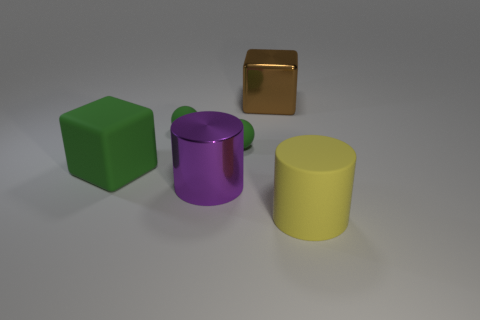Is the color of the metallic cylinder the same as the big cylinder in front of the big shiny cylinder?
Your answer should be compact. No. Is the number of purple shiny things greater than the number of metal objects?
Offer a terse response. No. There is another metallic thing that is the same shape as the yellow object; what is its size?
Ensure brevity in your answer.  Large. Does the large purple cylinder have the same material as the big brown cube on the left side of the big yellow cylinder?
Offer a terse response. Yes. How many objects are big yellow rubber cylinders or blue cubes?
Provide a short and direct response. 1. Do the green ball on the left side of the purple thing and the rubber thing that is right of the big brown metal thing have the same size?
Provide a succinct answer. No. What number of cylinders are either large purple metallic things or yellow matte things?
Provide a short and direct response. 2. Is there a big yellow shiny ball?
Provide a short and direct response. No. Are there any other things that are the same shape as the yellow rubber object?
Provide a succinct answer. Yes. Is the large shiny block the same color as the large matte cylinder?
Give a very brief answer. No. 